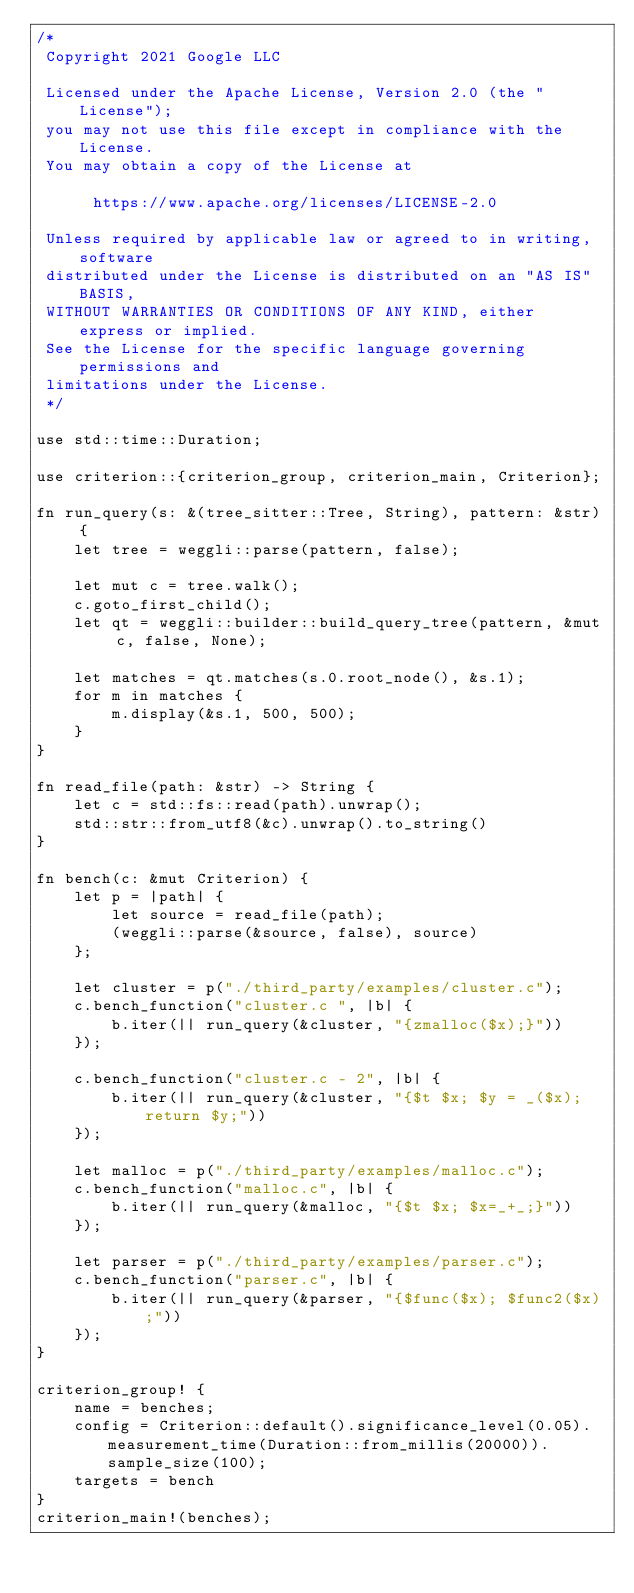Convert code to text. <code><loc_0><loc_0><loc_500><loc_500><_Rust_>/*
 Copyright 2021 Google LLC

 Licensed under the Apache License, Version 2.0 (the "License");
 you may not use this file except in compliance with the License.
 You may obtain a copy of the License at

      https://www.apache.org/licenses/LICENSE-2.0

 Unless required by applicable law or agreed to in writing, software
 distributed under the License is distributed on an "AS IS" BASIS,
 WITHOUT WARRANTIES OR CONDITIONS OF ANY KIND, either express or implied.
 See the License for the specific language governing permissions and
 limitations under the License.
 */

use std::time::Duration;

use criterion::{criterion_group, criterion_main, Criterion};

fn run_query(s: &(tree_sitter::Tree, String), pattern: &str) {
    let tree = weggli::parse(pattern, false);

    let mut c = tree.walk();
    c.goto_first_child();
    let qt = weggli::builder::build_query_tree(pattern, &mut c, false, None);

    let matches = qt.matches(s.0.root_node(), &s.1);
    for m in matches {
        m.display(&s.1, 500, 500);
    }
}

fn read_file(path: &str) -> String {
    let c = std::fs::read(path).unwrap();
    std::str::from_utf8(&c).unwrap().to_string()
}

fn bench(c: &mut Criterion) {
    let p = |path| {
        let source = read_file(path);
        (weggli::parse(&source, false), source)
    };

    let cluster = p("./third_party/examples/cluster.c");
    c.bench_function("cluster.c ", |b| {
        b.iter(|| run_query(&cluster, "{zmalloc($x);}"))
    });

    c.bench_function("cluster.c - 2", |b| {
        b.iter(|| run_query(&cluster, "{$t $x; $y = _($x); return $y;"))
    });

    let malloc = p("./third_party/examples/malloc.c");
    c.bench_function("malloc.c", |b| {
        b.iter(|| run_query(&malloc, "{$t $x; $x=_+_;}"))
    });

    let parser = p("./third_party/examples/parser.c");
    c.bench_function("parser.c", |b| {
        b.iter(|| run_query(&parser, "{$func($x); $func2($x);"))
    });
}

criterion_group! {
    name = benches;
    config = Criterion::default().significance_level(0.05).measurement_time(Duration::from_millis(20000)).sample_size(100);
    targets = bench
}
criterion_main!(benches);
</code> 